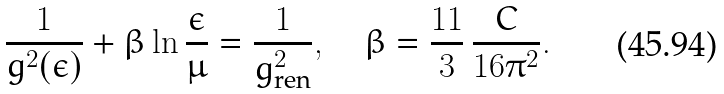Convert formula to latex. <formula><loc_0><loc_0><loc_500><loc_500>\frac { 1 } { g ^ { 2 } ( \epsilon ) } + \beta \ln \frac { \epsilon } { \mu } = \frac { 1 } { g _ { \text {ren} } ^ { 2 } } , \quad \beta = \frac { 1 1 } { 3 } \, \frac { C } { 1 6 \pi ^ { 2 } } .</formula> 